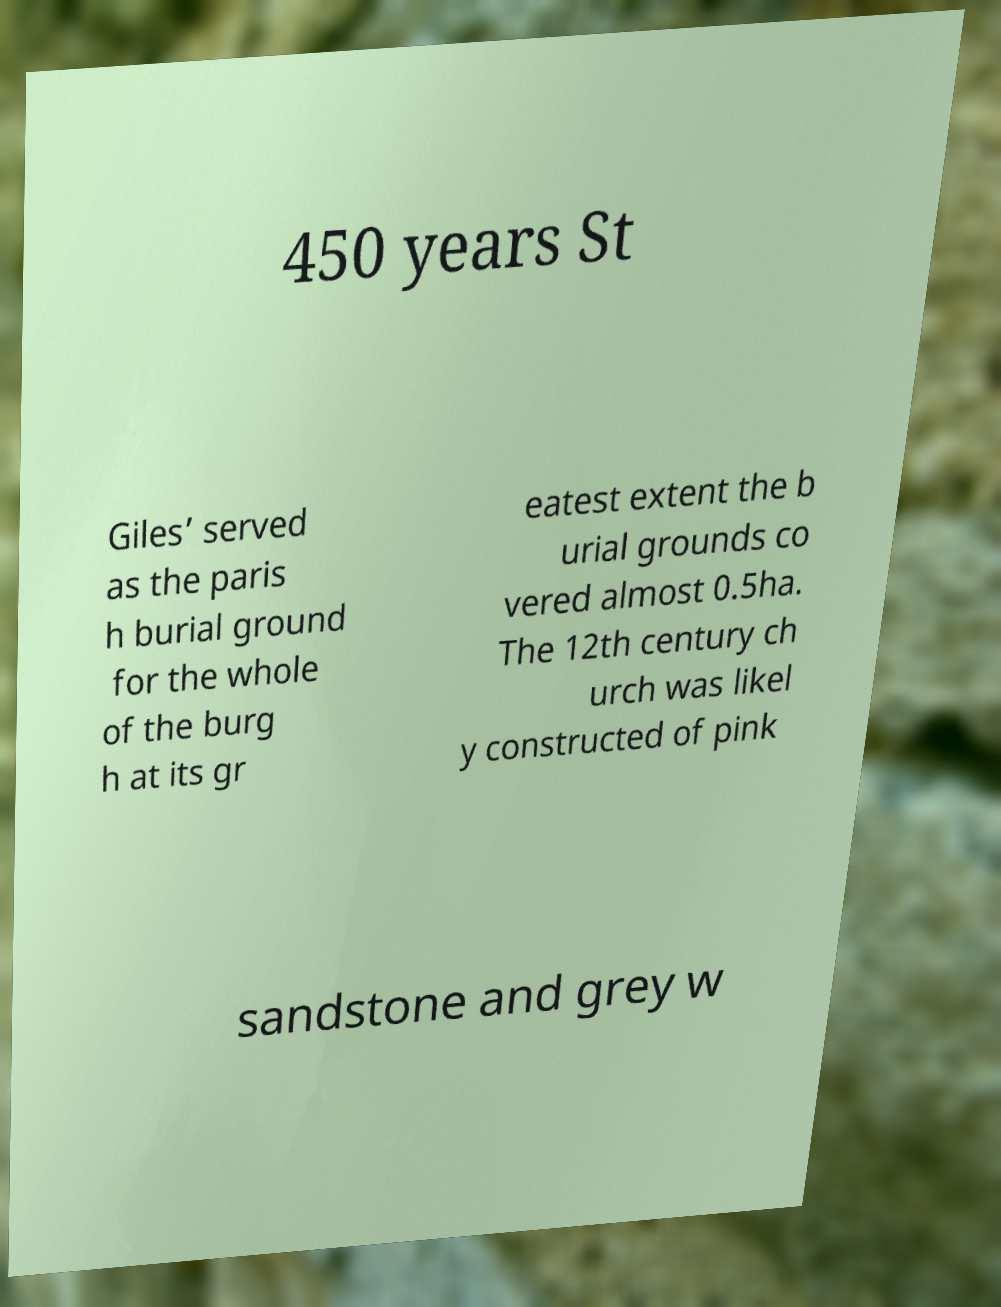Could you extract and type out the text from this image? 450 years St Giles’ served as the paris h burial ground for the whole of the burg h at its gr eatest extent the b urial grounds co vered almost 0.5ha. The 12th century ch urch was likel y constructed of pink sandstone and grey w 